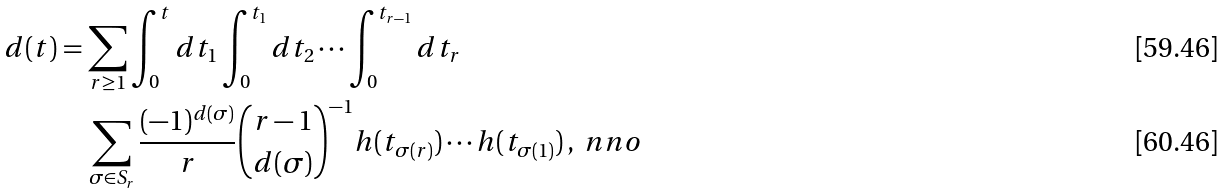<formula> <loc_0><loc_0><loc_500><loc_500>d ( t ) & = \sum _ { r \geq 1 } \int _ { 0 } ^ { t } d t _ { 1 } \int _ { 0 } ^ { t _ { 1 } } d t _ { 2 } \cdots \int _ { 0 } ^ { t _ { r - 1 } } d t _ { r } \\ & \quad \sum _ { \sigma \in { S } _ { r } } \frac { ( - 1 ) ^ { d ( \sigma ) } } { r } \binom { r - 1 } { d ( \sigma ) } ^ { - 1 } h ( t _ { \sigma ( r ) } ) \cdots h ( t _ { \sigma ( 1 ) } ) \, , \ n n o</formula> 